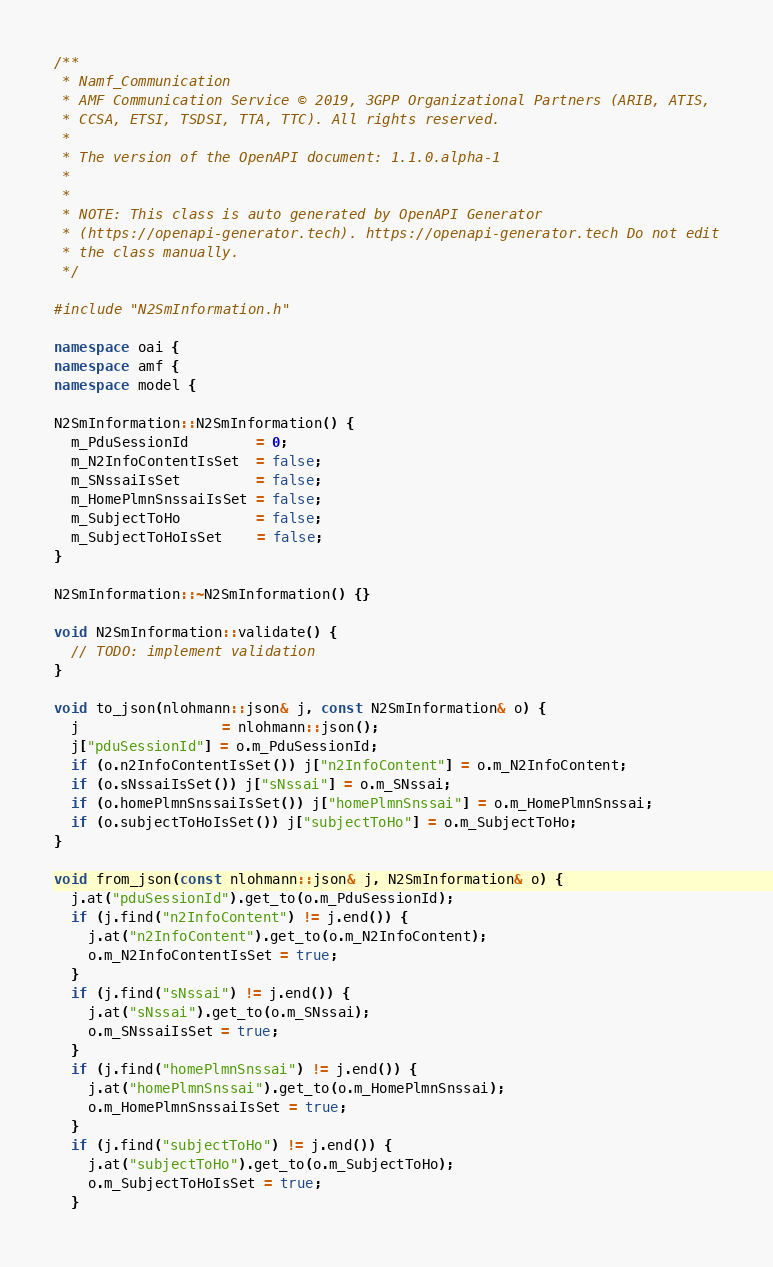Convert code to text. <code><loc_0><loc_0><loc_500><loc_500><_C++_>/**
 * Namf_Communication
 * AMF Communication Service © 2019, 3GPP Organizational Partners (ARIB, ATIS,
 * CCSA, ETSI, TSDSI, TTA, TTC). All rights reserved.
 *
 * The version of the OpenAPI document: 1.1.0.alpha-1
 *
 *
 * NOTE: This class is auto generated by OpenAPI Generator
 * (https://openapi-generator.tech). https://openapi-generator.tech Do not edit
 * the class manually.
 */

#include "N2SmInformation.h"

namespace oai {
namespace amf {
namespace model {

N2SmInformation::N2SmInformation() {
  m_PduSessionId        = 0;
  m_N2InfoContentIsSet  = false;
  m_SNssaiIsSet         = false;
  m_HomePlmnSnssaiIsSet = false;
  m_SubjectToHo         = false;
  m_SubjectToHoIsSet    = false;
}

N2SmInformation::~N2SmInformation() {}

void N2SmInformation::validate() {
  // TODO: implement validation
}

void to_json(nlohmann::json& j, const N2SmInformation& o) {
  j                 = nlohmann::json();
  j["pduSessionId"] = o.m_PduSessionId;
  if (o.n2InfoContentIsSet()) j["n2InfoContent"] = o.m_N2InfoContent;
  if (o.sNssaiIsSet()) j["sNssai"] = o.m_SNssai;
  if (o.homePlmnSnssaiIsSet()) j["homePlmnSnssai"] = o.m_HomePlmnSnssai;
  if (o.subjectToHoIsSet()) j["subjectToHo"] = o.m_SubjectToHo;
}

void from_json(const nlohmann::json& j, N2SmInformation& o) {
  j.at("pduSessionId").get_to(o.m_PduSessionId);
  if (j.find("n2InfoContent") != j.end()) {
    j.at("n2InfoContent").get_to(o.m_N2InfoContent);
    o.m_N2InfoContentIsSet = true;
  }
  if (j.find("sNssai") != j.end()) {
    j.at("sNssai").get_to(o.m_SNssai);
    o.m_SNssaiIsSet = true;
  }
  if (j.find("homePlmnSnssai") != j.end()) {
    j.at("homePlmnSnssai").get_to(o.m_HomePlmnSnssai);
    o.m_HomePlmnSnssaiIsSet = true;
  }
  if (j.find("subjectToHo") != j.end()) {
    j.at("subjectToHo").get_to(o.m_SubjectToHo);
    o.m_SubjectToHoIsSet = true;
  }</code> 